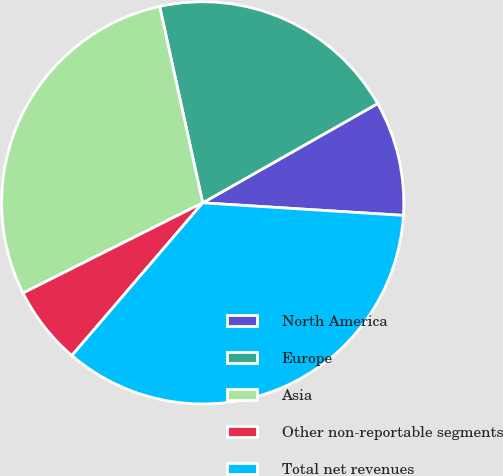Convert chart to OTSL. <chart><loc_0><loc_0><loc_500><loc_500><pie_chart><fcel>North America<fcel>Europe<fcel>Asia<fcel>Other non-reportable segments<fcel>Total net revenues<nl><fcel>9.21%<fcel>20.22%<fcel>28.97%<fcel>6.32%<fcel>35.28%<nl></chart> 